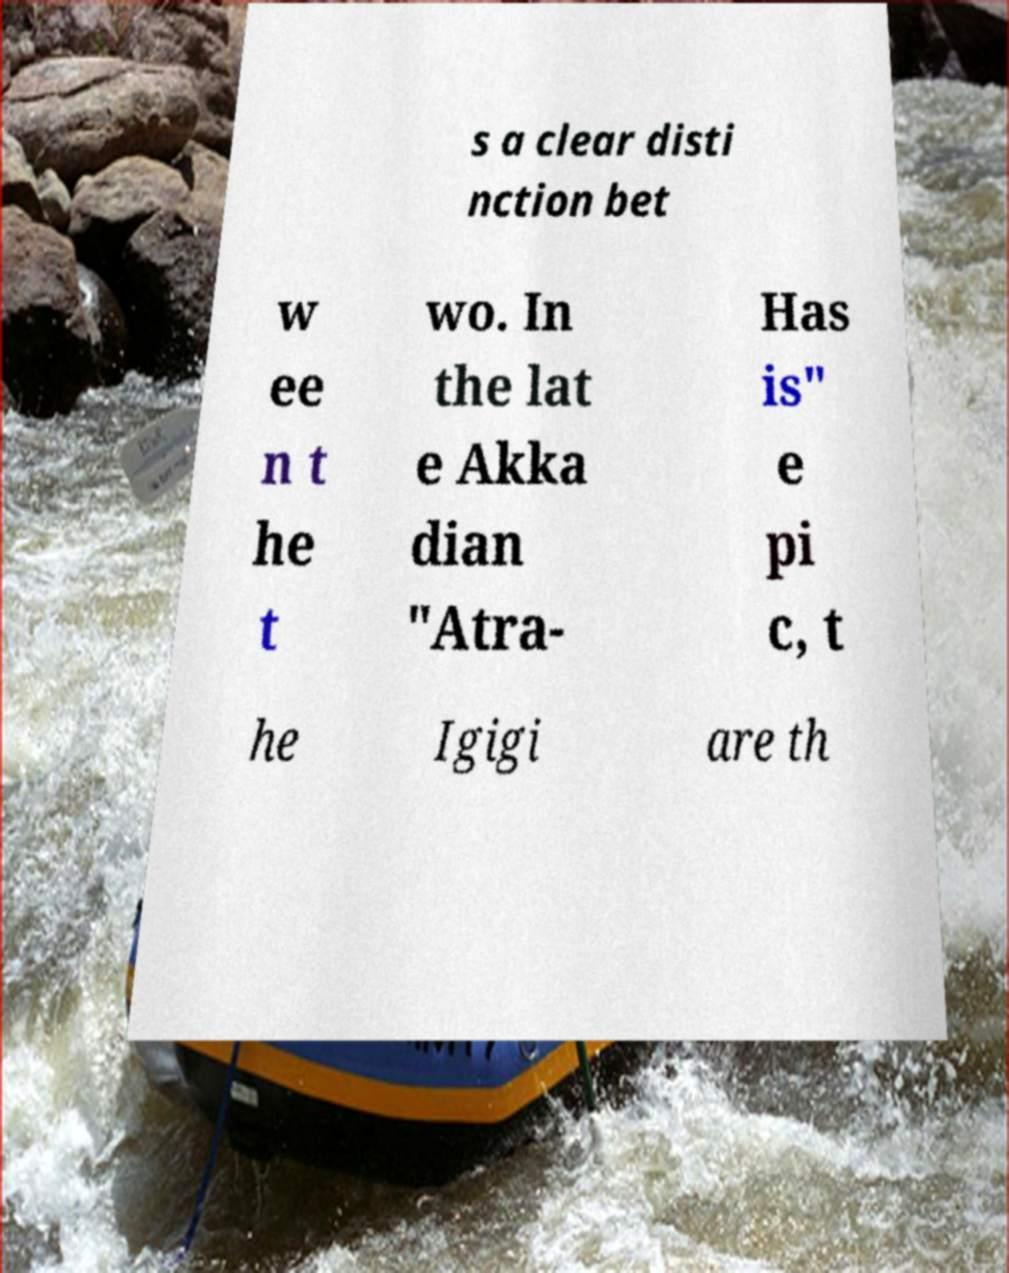For documentation purposes, I need the text within this image transcribed. Could you provide that? s a clear disti nction bet w ee n t he t wo. In the lat e Akka dian "Atra- Has is" e pi c, t he Igigi are th 